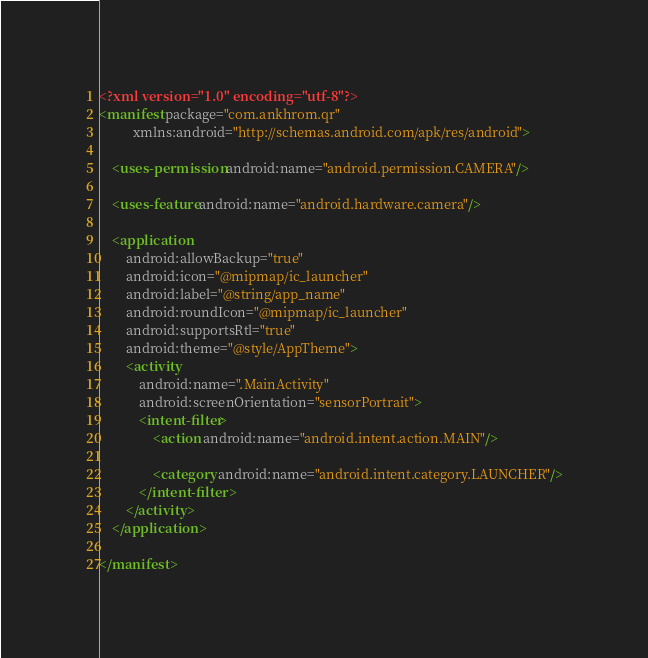Convert code to text. <code><loc_0><loc_0><loc_500><loc_500><_XML_><?xml version="1.0" encoding="utf-8"?>
<manifest package="com.ankhrom.qr"
          xmlns:android="http://schemas.android.com/apk/res/android">

    <uses-permission android:name="android.permission.CAMERA"/>

    <uses-feature android:name="android.hardware.camera"/>

    <application
        android:allowBackup="true"
        android:icon="@mipmap/ic_launcher"
        android:label="@string/app_name"
        android:roundIcon="@mipmap/ic_launcher"
        android:supportsRtl="true"
        android:theme="@style/AppTheme">
        <activity
            android:name=".MainActivity"
            android:screenOrientation="sensorPortrait">
            <intent-filter>
                <action android:name="android.intent.action.MAIN"/>

                <category android:name="android.intent.category.LAUNCHER"/>
            </intent-filter>
        </activity>
    </application>

</manifest></code> 